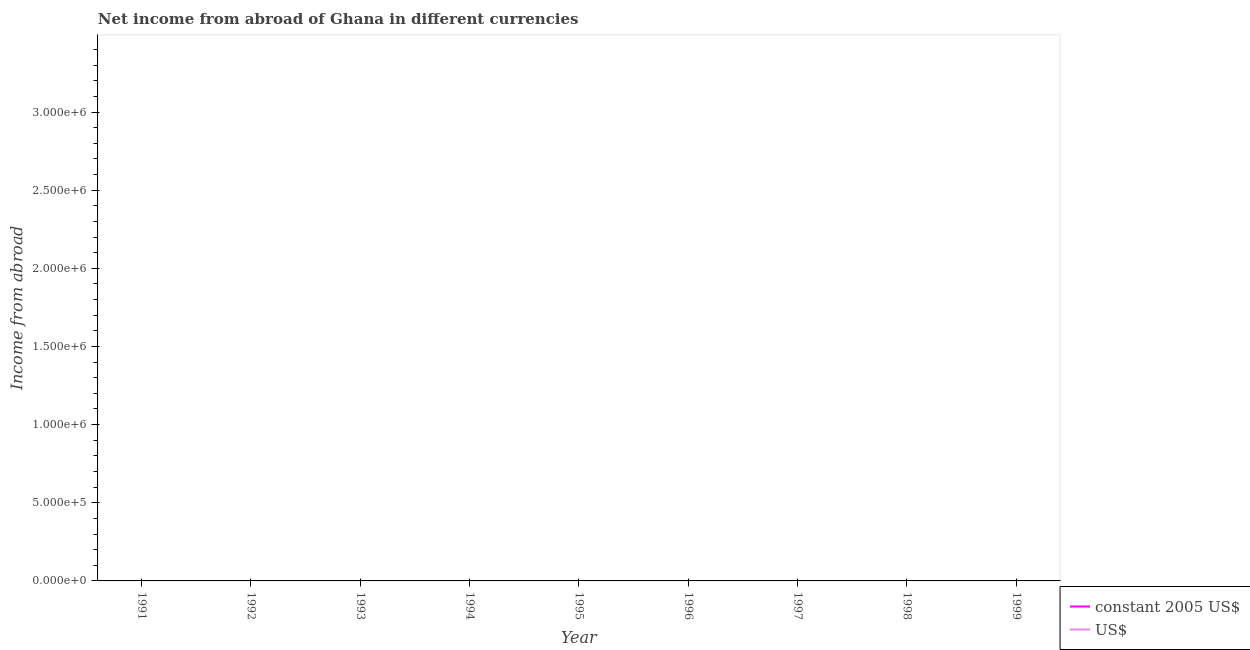How many different coloured lines are there?
Offer a terse response. 0. Across all years, what is the minimum income from abroad in constant 2005 us$?
Offer a very short reply. 0. What is the total income from abroad in us$ in the graph?
Make the answer very short. 0. In how many years, is the income from abroad in constant 2005 us$ greater than 2000000 units?
Provide a succinct answer. 0. Does the income from abroad in constant 2005 us$ monotonically increase over the years?
Ensure brevity in your answer.  No. Is the income from abroad in constant 2005 us$ strictly greater than the income from abroad in us$ over the years?
Offer a very short reply. Yes. Is the income from abroad in constant 2005 us$ strictly less than the income from abroad in us$ over the years?
Make the answer very short. No. How many lines are there?
Provide a short and direct response. 0. What is the difference between two consecutive major ticks on the Y-axis?
Give a very brief answer. 5.00e+05. Does the graph contain grids?
Provide a short and direct response. No. How many legend labels are there?
Make the answer very short. 2. How are the legend labels stacked?
Give a very brief answer. Vertical. What is the title of the graph?
Your response must be concise. Net income from abroad of Ghana in different currencies. Does "Health Care" appear as one of the legend labels in the graph?
Provide a short and direct response. No. What is the label or title of the Y-axis?
Give a very brief answer. Income from abroad. What is the Income from abroad of US$ in 1991?
Provide a succinct answer. 0. What is the Income from abroad of constant 2005 US$ in 1993?
Your answer should be compact. 0. What is the Income from abroad of constant 2005 US$ in 1994?
Ensure brevity in your answer.  0. What is the Income from abroad in constant 2005 US$ in 1995?
Offer a terse response. 0. What is the Income from abroad in US$ in 1995?
Your answer should be very brief. 0. What is the Income from abroad of constant 2005 US$ in 1996?
Your answer should be very brief. 0. What is the Income from abroad of US$ in 1996?
Offer a terse response. 0. What is the Income from abroad of constant 2005 US$ in 1997?
Provide a short and direct response. 0. What is the Income from abroad in US$ in 1998?
Offer a terse response. 0. What is the Income from abroad of constant 2005 US$ in 1999?
Your answer should be compact. 0. What is the Income from abroad of US$ in 1999?
Make the answer very short. 0. What is the total Income from abroad in constant 2005 US$ in the graph?
Your answer should be very brief. 0. What is the average Income from abroad in US$ per year?
Give a very brief answer. 0. 